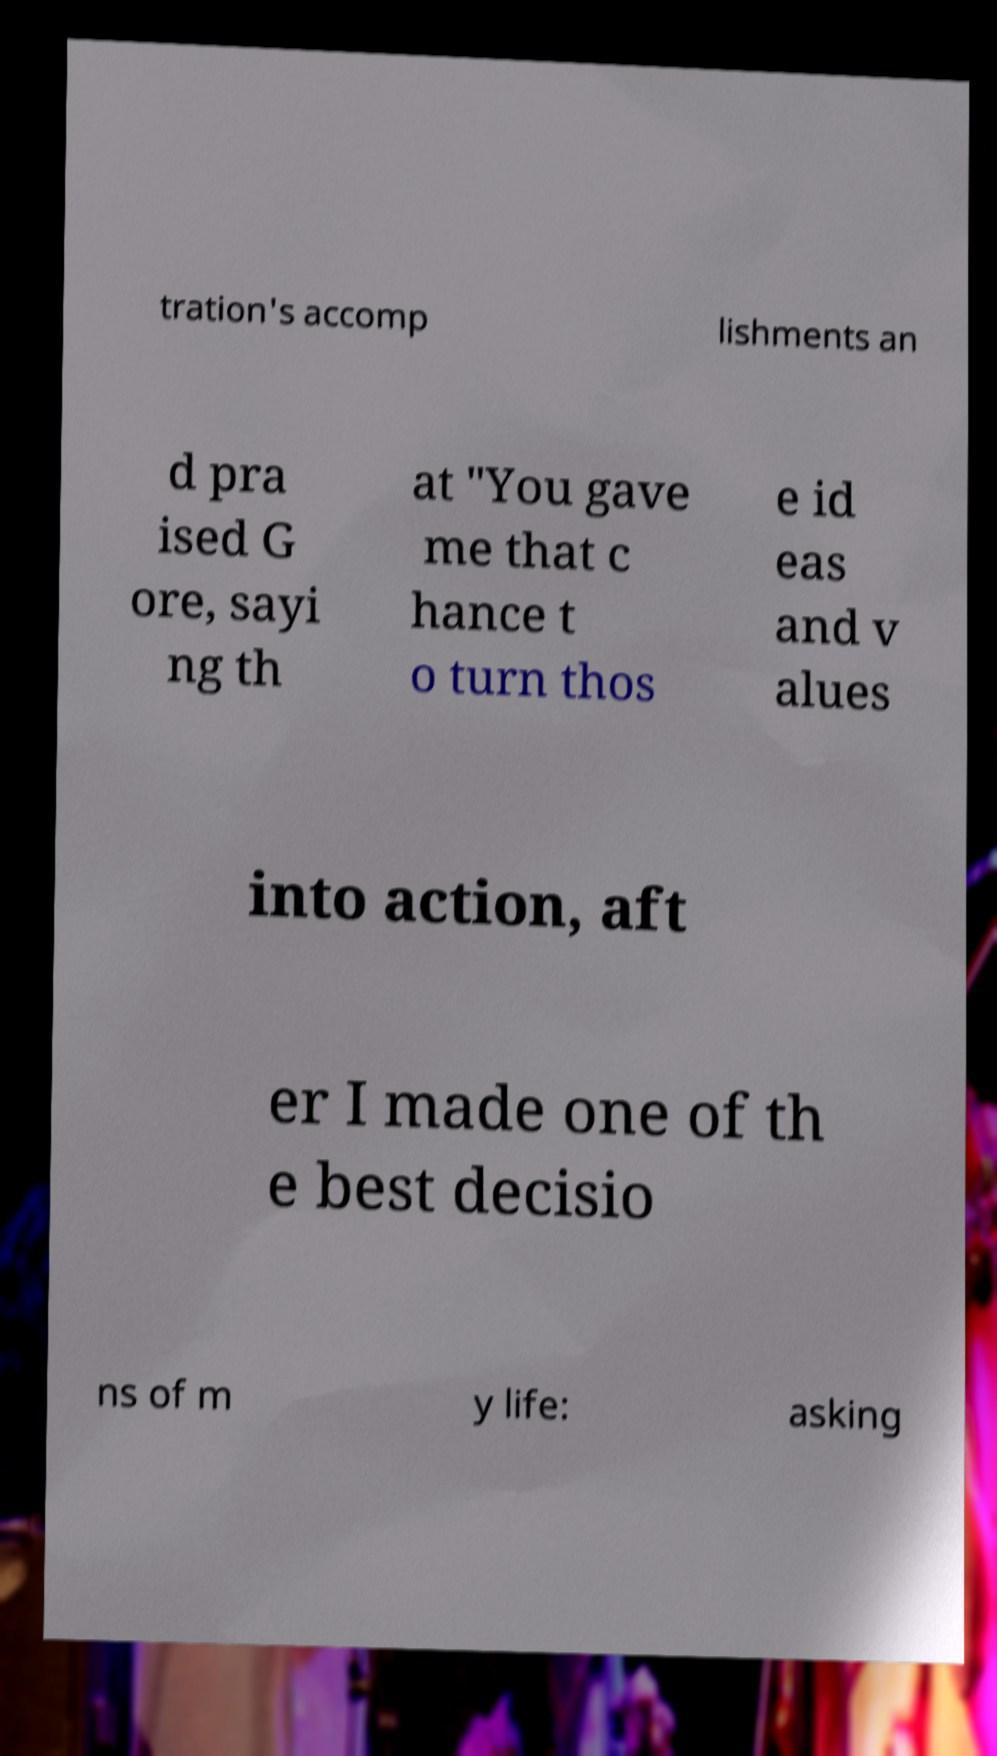Can you accurately transcribe the text from the provided image for me? tration's accomp lishments an d pra ised G ore, sayi ng th at "You gave me that c hance t o turn thos e id eas and v alues into action, aft er I made one of th e best decisio ns of m y life: asking 